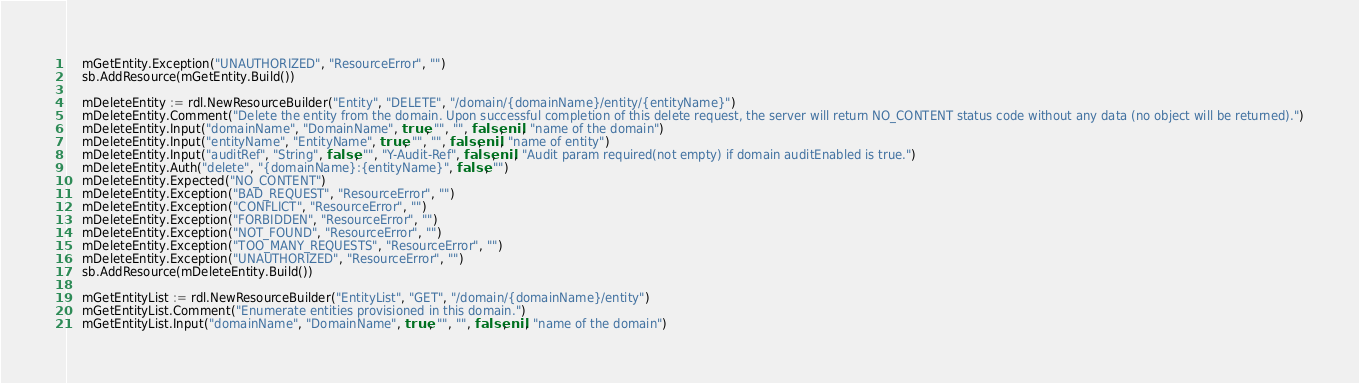Convert code to text. <code><loc_0><loc_0><loc_500><loc_500><_Go_>	mGetEntity.Exception("UNAUTHORIZED", "ResourceError", "")
	sb.AddResource(mGetEntity.Build())

	mDeleteEntity := rdl.NewResourceBuilder("Entity", "DELETE", "/domain/{domainName}/entity/{entityName}")
	mDeleteEntity.Comment("Delete the entity from the domain. Upon successful completion of this delete request, the server will return NO_CONTENT status code without any data (no object will be returned).")
	mDeleteEntity.Input("domainName", "DomainName", true, "", "", false, nil, "name of the domain")
	mDeleteEntity.Input("entityName", "EntityName", true, "", "", false, nil, "name of entity")
	mDeleteEntity.Input("auditRef", "String", false, "", "Y-Audit-Ref", false, nil, "Audit param required(not empty) if domain auditEnabled is true.")
	mDeleteEntity.Auth("delete", "{domainName}:{entityName}", false, "")
	mDeleteEntity.Expected("NO_CONTENT")
	mDeleteEntity.Exception("BAD_REQUEST", "ResourceError", "")
	mDeleteEntity.Exception("CONFLICT", "ResourceError", "")
	mDeleteEntity.Exception("FORBIDDEN", "ResourceError", "")
	mDeleteEntity.Exception("NOT_FOUND", "ResourceError", "")
	mDeleteEntity.Exception("TOO_MANY_REQUESTS", "ResourceError", "")
	mDeleteEntity.Exception("UNAUTHORIZED", "ResourceError", "")
	sb.AddResource(mDeleteEntity.Build())

	mGetEntityList := rdl.NewResourceBuilder("EntityList", "GET", "/domain/{domainName}/entity")
	mGetEntityList.Comment("Enumerate entities provisioned in this domain.")
	mGetEntityList.Input("domainName", "DomainName", true, "", "", false, nil, "name of the domain")</code> 